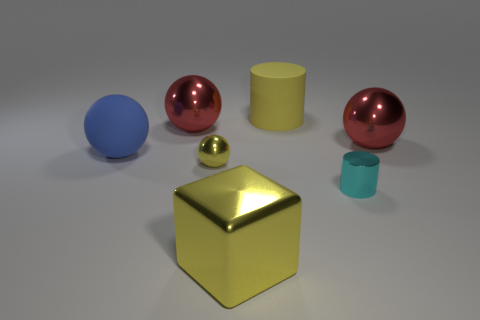Subtract all yellow shiny spheres. How many spheres are left? 3 Add 1 small yellow metal cubes. How many objects exist? 8 Subtract all blue balls. How many balls are left? 3 Subtract all blocks. How many objects are left? 6 Subtract 2 cylinders. How many cylinders are left? 0 Subtract all green cylinders. Subtract all gray spheres. How many cylinders are left? 2 Subtract all red blocks. How many red spheres are left? 2 Subtract all blue rubber things. Subtract all metal cubes. How many objects are left? 5 Add 5 large matte spheres. How many large matte spheres are left? 6 Add 3 small cylinders. How many small cylinders exist? 4 